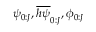Convert formula to latex. <formula><loc_0><loc_0><loc_500><loc_500>\psi _ { 0 \colon J } , \overline { h \psi } _ { 0 \colon J } , \phi _ { 0 \colon J }</formula> 